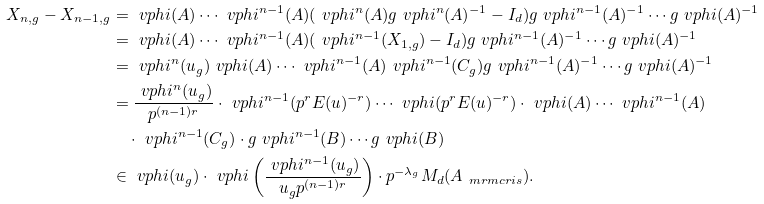Convert formula to latex. <formula><loc_0><loc_0><loc_500><loc_500>X _ { n , g } - X _ { n - 1 , g } & = \ v p h i ( A ) \cdots \ v p h i ^ { n - 1 } ( A ) ( \ v p h i ^ { n } ( A ) g \ v p h i ^ { n } ( A ) ^ { - 1 } - I _ { d } ) g \ v p h i ^ { n - 1 } ( A ) ^ { - 1 } \cdots g \ v p h i ( A ) ^ { - 1 } \\ & = \ v p h i ( A ) \cdots \ v p h i ^ { n - 1 } ( A ) ( \ v p h i ^ { n - 1 } ( X _ { 1 , g } ) - I _ { d } ) g \ v p h i ^ { n - 1 } ( A ) ^ { - 1 } \cdots g \ v p h i ( A ) ^ { - 1 } \\ & = \ v p h i ^ { n } ( u _ { g } ) \ v p h i ( A ) \cdots \ v p h i ^ { n - 1 } ( A ) \ v p h i ^ { n - 1 } ( C _ { g } ) g \ v p h i ^ { n - 1 } ( A ) ^ { - 1 } \cdots g \ v p h i ( A ) ^ { - 1 } \\ & = \frac { \ v p h i ^ { n } ( u _ { g } ) } { p ^ { ( n - 1 ) r } } \cdot \ v p h i ^ { n - 1 } ( p ^ { r } E ( u ) ^ { - r } ) \cdots \ v p h i ( p ^ { r } E ( u ) ^ { - r } ) \cdot \ v p h i ( A ) \cdots \ v p h i ^ { n - 1 } ( A ) \\ & \quad \cdot \ v p h i ^ { n - 1 } ( C _ { g } ) \cdot g \ v p h i ^ { n - 1 } ( B ) \cdots g \ v p h i ( B ) \\ & \in \ v p h i ( u _ { g } ) \cdot \ v p h i \left ( \frac { \ v p h i ^ { n - 1 } ( u _ { g } ) } { u _ { g } p ^ { ( n - 1 ) r } } \right ) \cdot p ^ { - \lambda _ { g } } M _ { d } ( A _ { \ m r m { c r i s } } ) .</formula> 